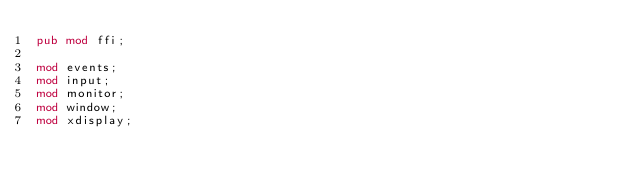<code> <loc_0><loc_0><loc_500><loc_500><_Rust_>pub mod ffi;

mod events;
mod input;
mod monitor;
mod window;
mod xdisplay;
</code> 